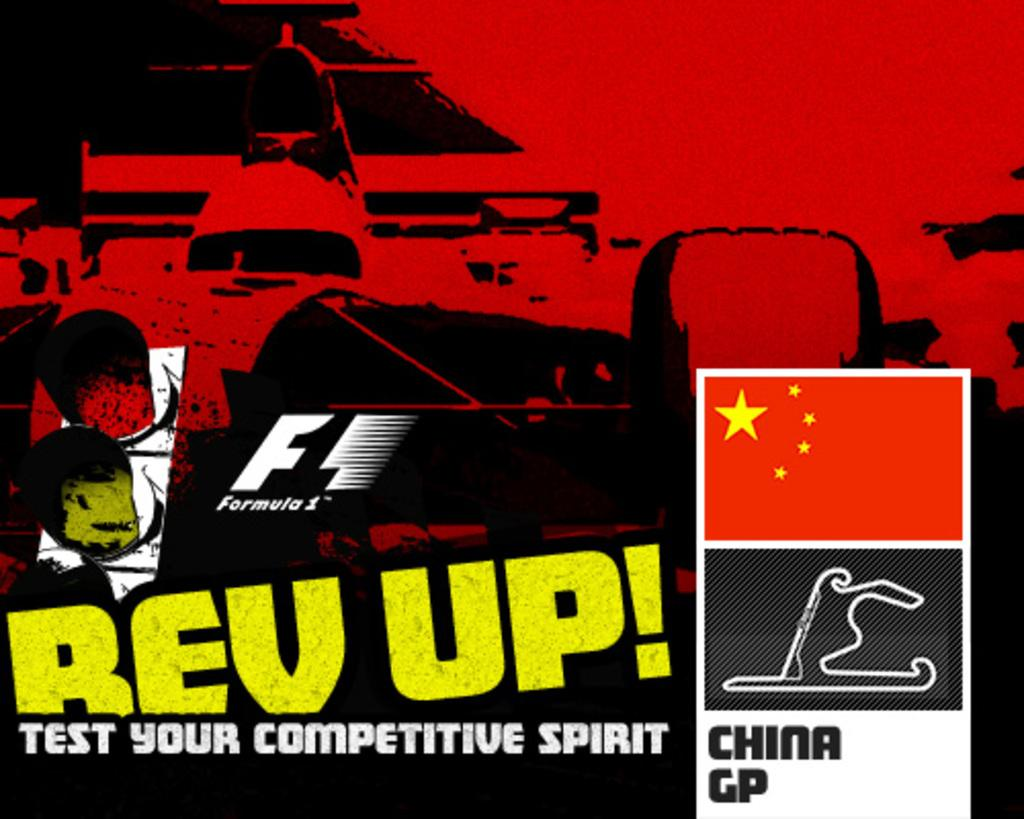What is present in the image that contains both text and images? There is a poster in the image that contains text and graphic images. What type of lock is featured in the graphic images on the poster? There is no lock present in the graphic images on the poster. 